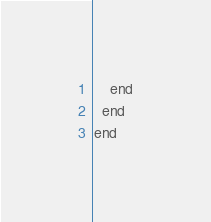<code> <loc_0><loc_0><loc_500><loc_500><_Ruby_>    end
  end
end
</code> 